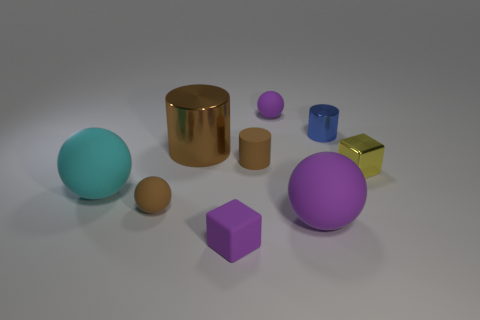What is the color of the metallic cylinder that is the same size as the cyan matte sphere?
Your answer should be very brief. Brown. Are there any cyan cylinders?
Keep it short and to the point. No. The small brown matte thing that is in front of the large cyan rubber ball has what shape?
Your answer should be very brief. Sphere. How many big spheres are right of the matte block and to the left of the brown metallic thing?
Offer a very short reply. 0. Are there any small blue cylinders made of the same material as the tiny blue object?
Make the answer very short. No. The matte ball that is the same color as the large metallic thing is what size?
Provide a succinct answer. Small. How many spheres are tiny cyan metal objects or blue shiny objects?
Provide a succinct answer. 0. What size is the cyan ball?
Offer a terse response. Large. There is a brown metal cylinder; how many tiny objects are to the right of it?
Offer a very short reply. 5. What is the size of the purple thing left of the tiny rubber thing that is behind the big brown metallic cylinder?
Keep it short and to the point. Small. 